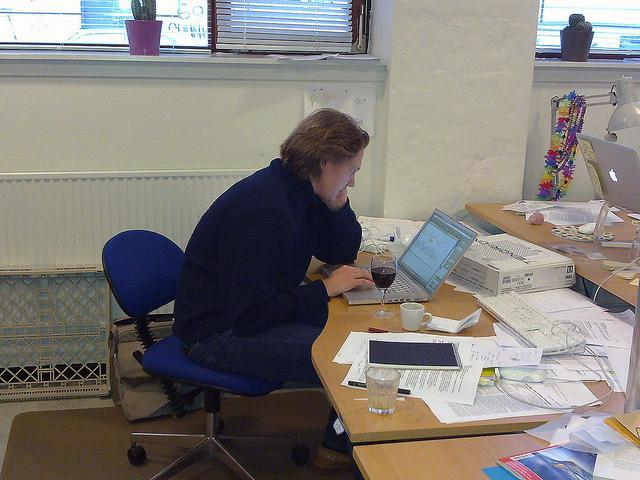Which liquid is most likely to be spilled on a laptop here? wine 